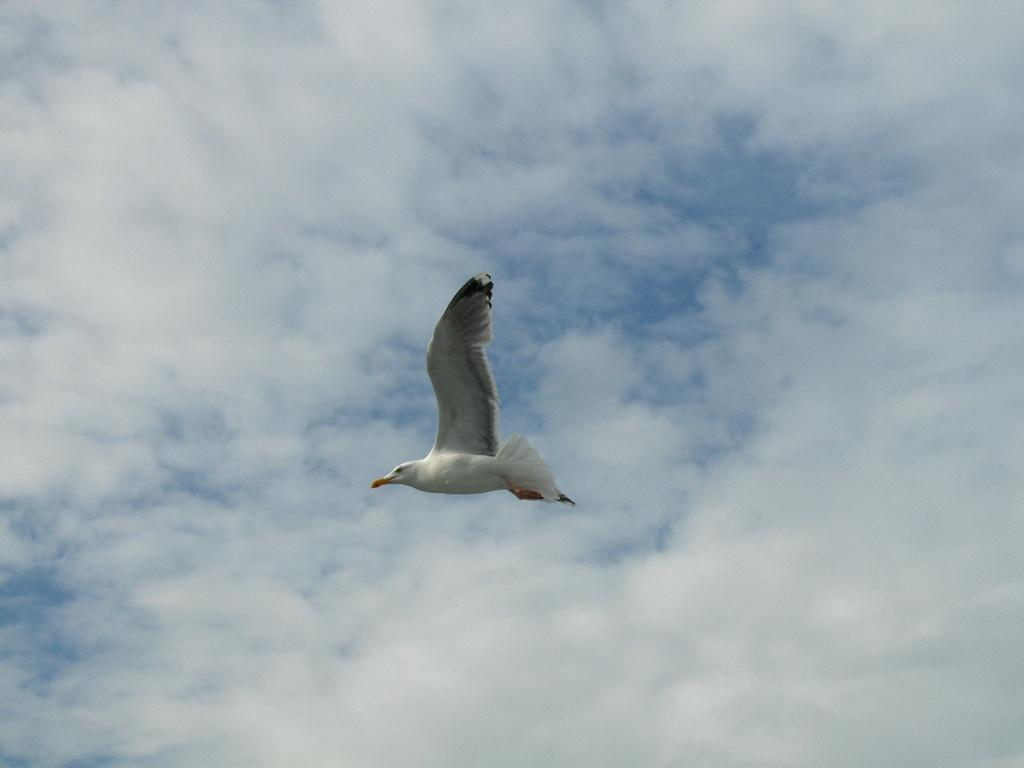What type of animal can be seen in the image? There is a bird in the image. What colors are present on the bird? The bird is white and gray in color. What is the bird doing in the image? The bird is flying. What can be seen in the background of the image? The sky is visible in the image. How would you describe the appearance of the sky? The sky is cloudy and pale blue in color. What is the name of the skin condition affecting the bird in the image? There is no indication of a skin condition affecting the bird in the image. The bird appears to be healthy and its colors are described as white and gray. 